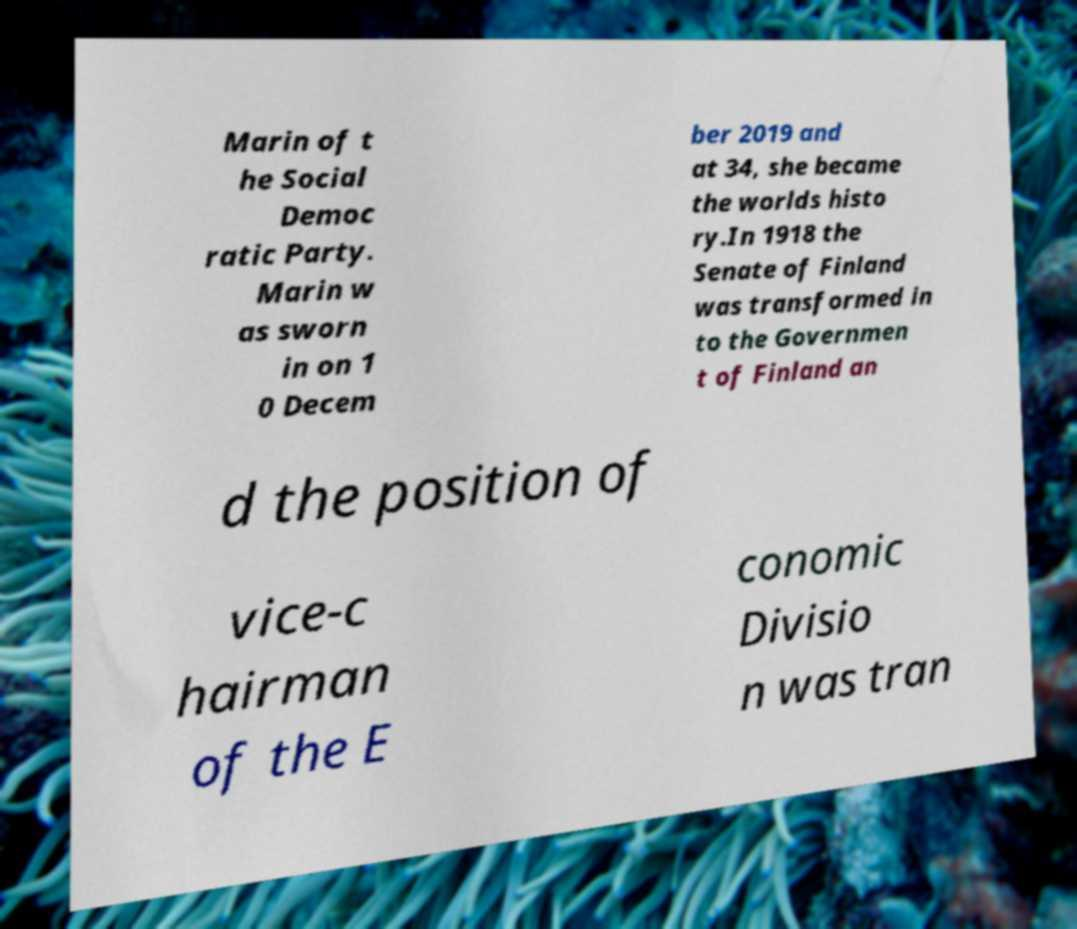Can you accurately transcribe the text from the provided image for me? Marin of t he Social Democ ratic Party. Marin w as sworn in on 1 0 Decem ber 2019 and at 34, she became the worlds histo ry.In 1918 the Senate of Finland was transformed in to the Governmen t of Finland an d the position of vice-c hairman of the E conomic Divisio n was tran 